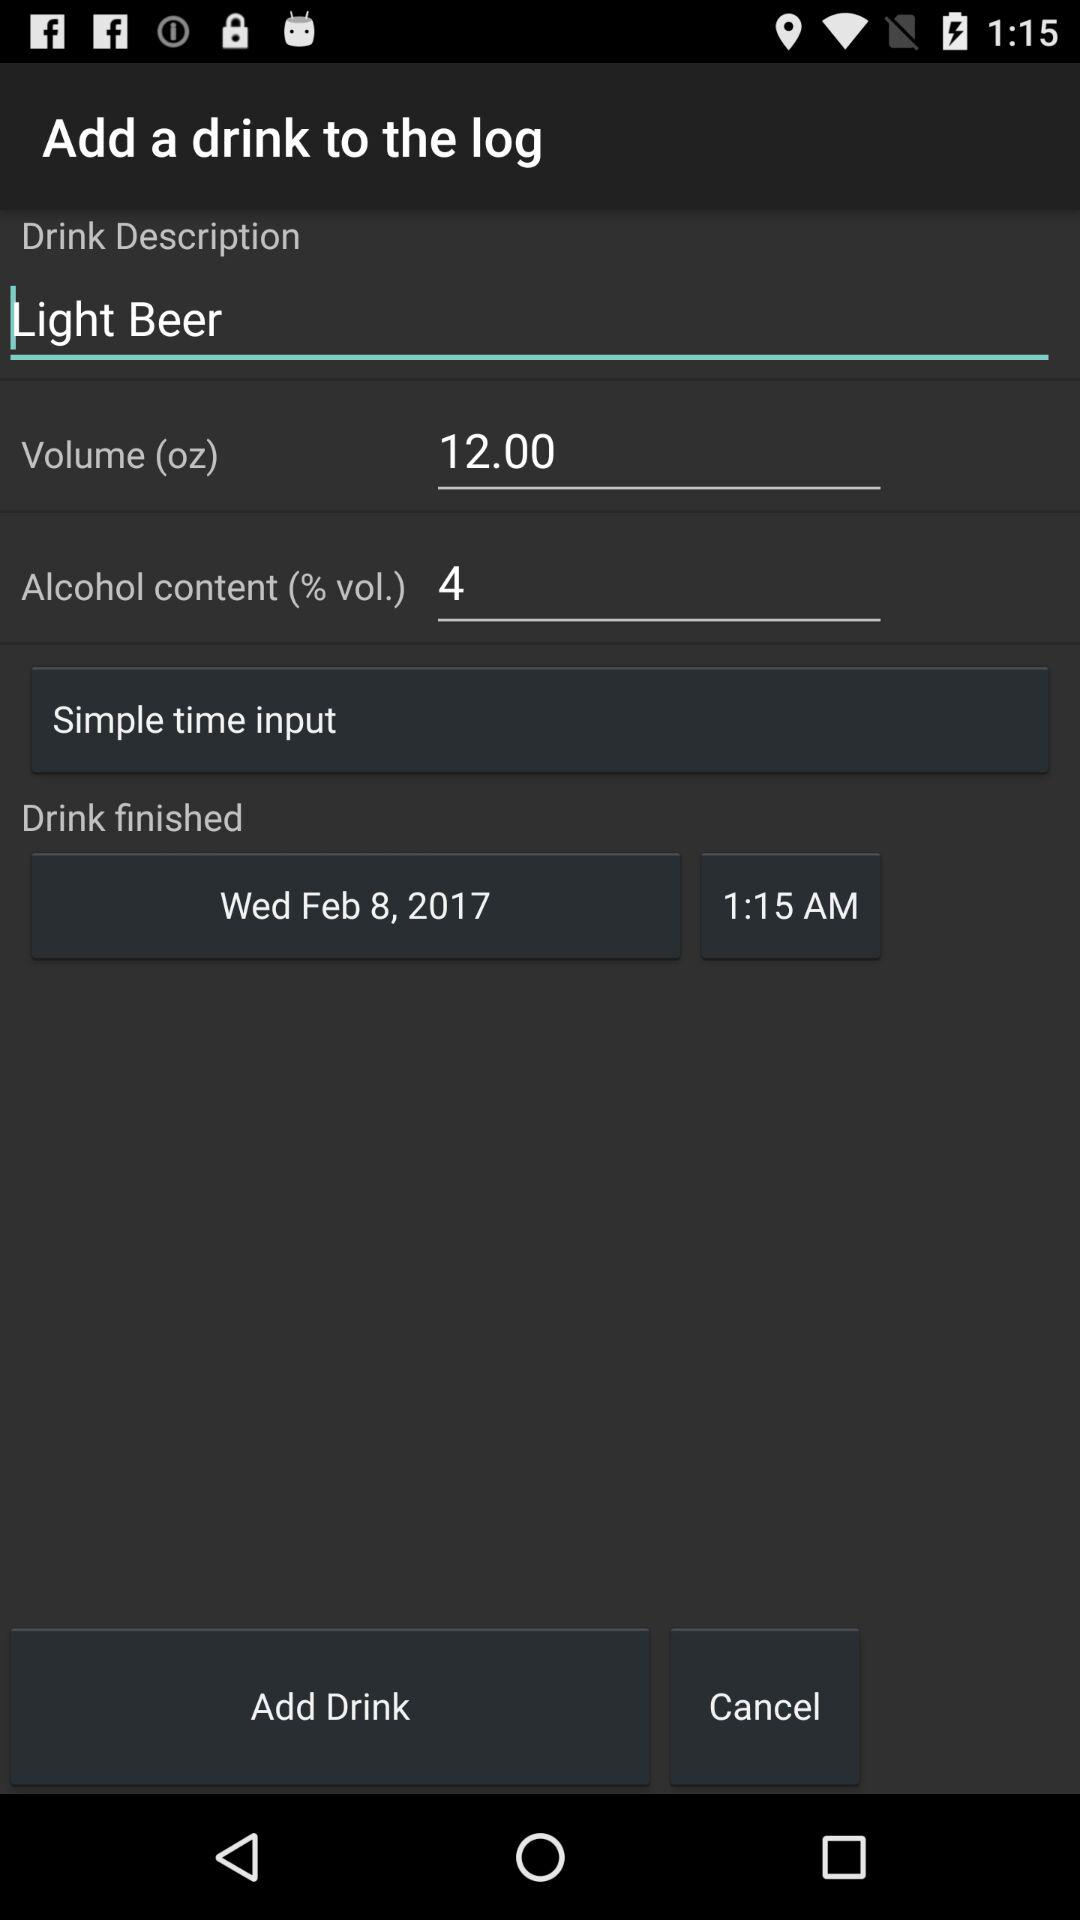What is the description of the drink? The description of the drink is "Light Beer". 